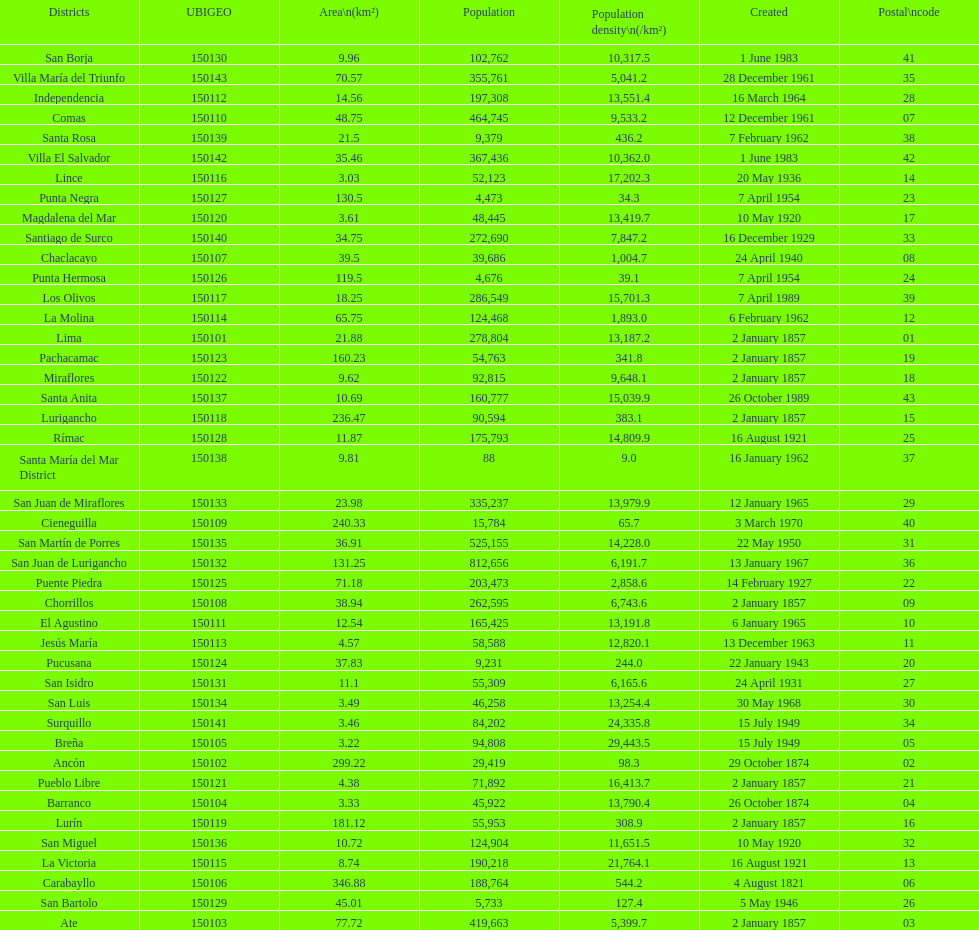How many districts have more than 100,000 people in this city? 21. 